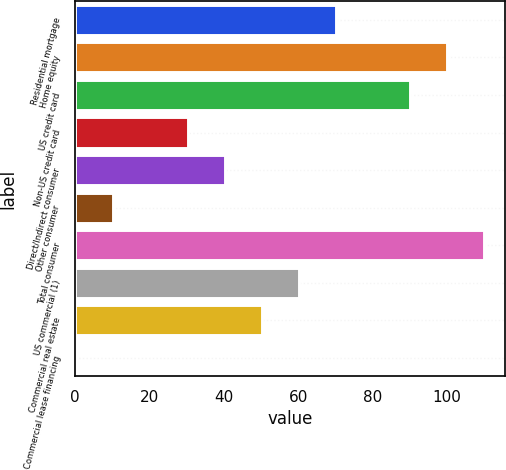<chart> <loc_0><loc_0><loc_500><loc_500><bar_chart><fcel>Residential mortgage<fcel>Home equity<fcel>US credit card<fcel>Non-US credit card<fcel>Direct/Indirect consumer<fcel>Other consumer<fcel>Total consumer<fcel>US commercial (1)<fcel>Commercial real estate<fcel>Commercial lease financing<nl><fcel>70.09<fcel>100<fcel>90.03<fcel>30.21<fcel>40.18<fcel>10.27<fcel>109.97<fcel>60.12<fcel>50.15<fcel>0.3<nl></chart> 